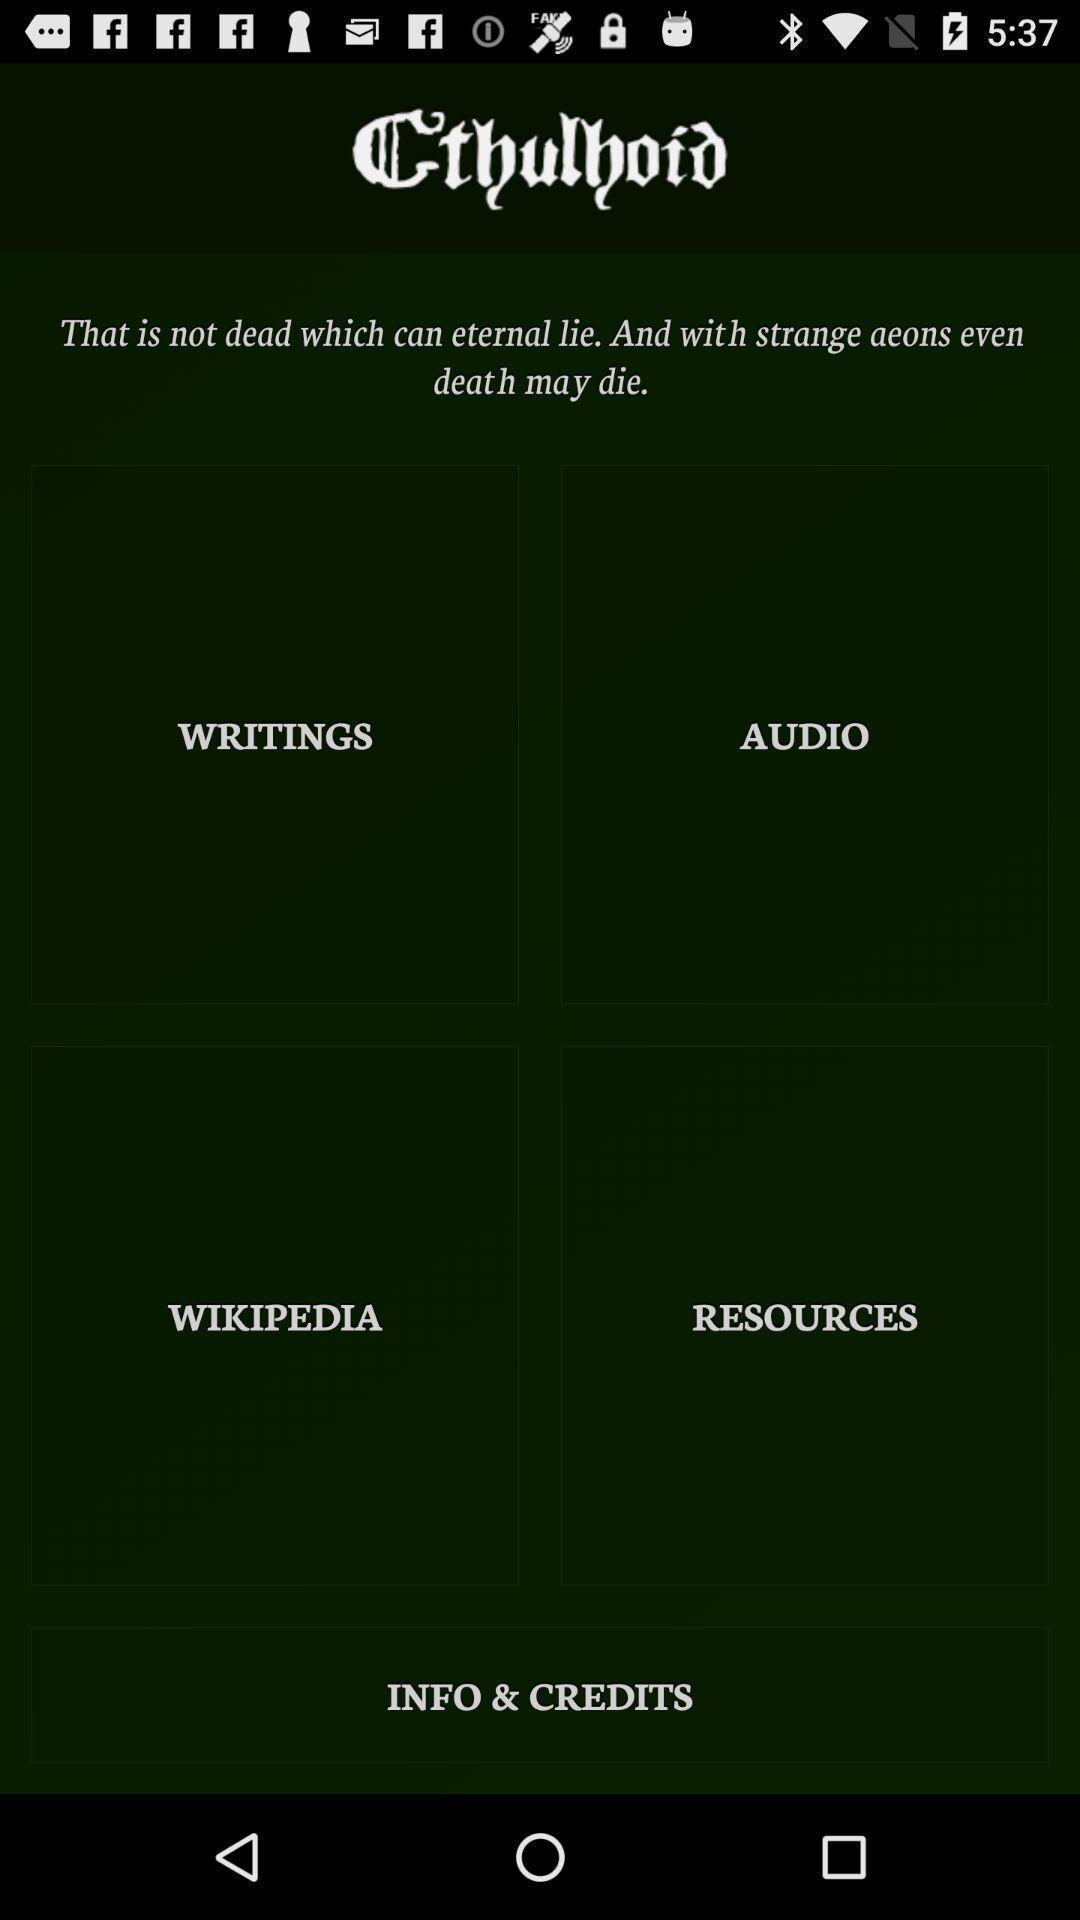Tell me what you see in this picture. Screen displaying different types of themes. 